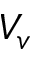Convert formula to latex. <formula><loc_0><loc_0><loc_500><loc_500>V _ { v }</formula> 